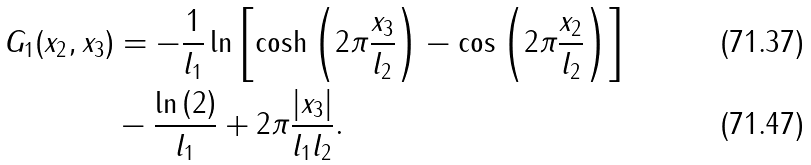Convert formula to latex. <formula><loc_0><loc_0><loc_500><loc_500>G _ { 1 } ( x _ { 2 } , x _ { 3 } ) & = - \frac { 1 } { l _ { 1 } } \ln \left [ \cosh \left ( 2 \pi \frac { x _ { 3 } } { l _ { 2 } } \right ) - \cos \left ( 2 \pi \frac { x _ { 2 } } { l _ { 2 } } \right ) \right ] \\ & - \frac { \ln \left ( 2 \right ) } { l _ { 1 } } + 2 \pi \frac { | x _ { 3 } | } { l _ { 1 } l _ { 2 } } .</formula> 